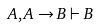<formula> <loc_0><loc_0><loc_500><loc_500>A , A \rightarrow B \vdash B</formula> 